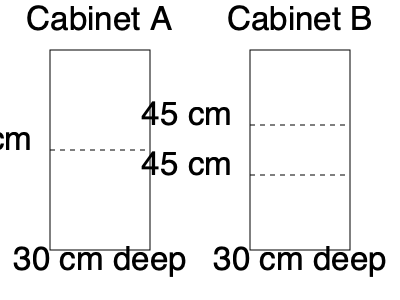Given the two cabinet designs shown above, both with the same height and depth, which cabinet offers more storage capacity? Assume all shelves are adjustable and spaced evenly. To determine which cabinet offers more storage capacity, we need to calculate the volume of each cabinet:

1. Cabinet A:
   - Height: 60 cm
   - Width: 30 cm
   - Depth: 30 cm
   - Volume = $60 \times 30 \times 30 = 54,000$ cm³

2. Cabinet B:
   - Height: 90 cm (45 cm + 45 cm)
   - Width: 30 cm
   - Depth: 30 cm
   - Volume = $90 \times 30 \times 30 = 81,000$ cm³

3. Comparison:
   Cabinet B has a larger volume (81,000 cm³) compared to Cabinet A (54,000 cm³).

4. Shelf consideration:
   Both cabinets have adjustable shelves, but Cabinet B has more vertical space, allowing for more flexible arrangement of items of various heights.

Therefore, Cabinet B offers more storage capacity due to its larger overall volume and greater flexibility in shelf arrangement.
Answer: Cabinet B 